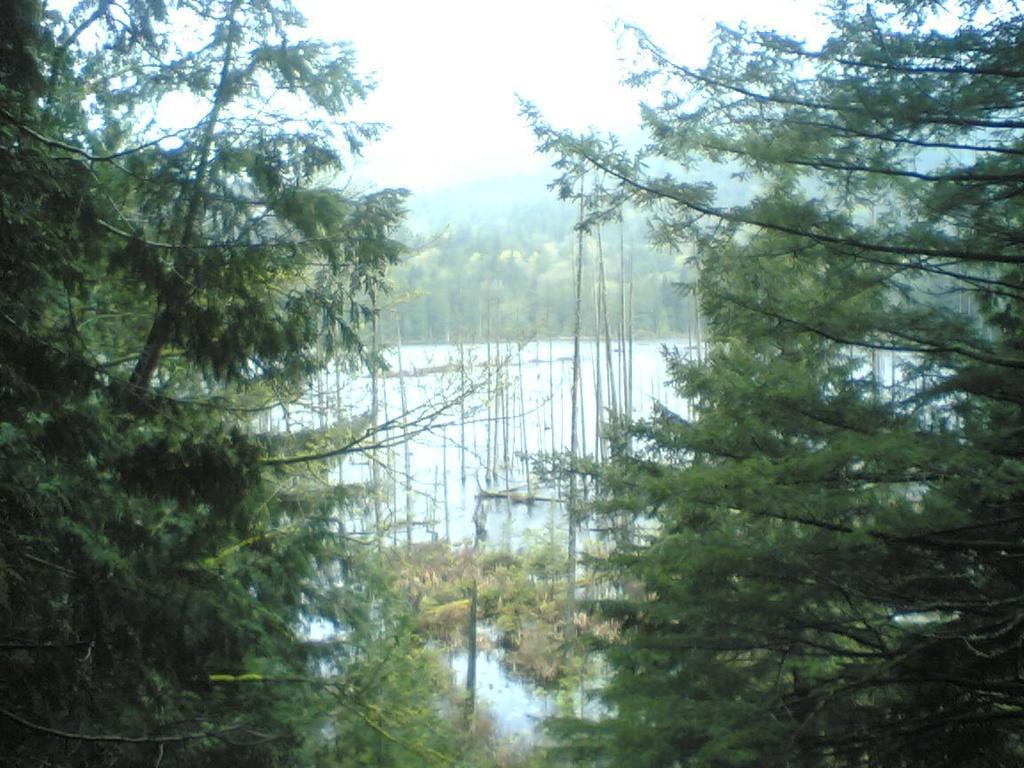Can you describe this image briefly? We can see trees, poles and water. In the background we can see trees and sky. 